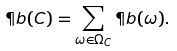<formula> <loc_0><loc_0><loc_500><loc_500>\P b ( C ) = \sum _ { \omega \in \Omega _ { C } } \P b ( \omega ) .</formula> 